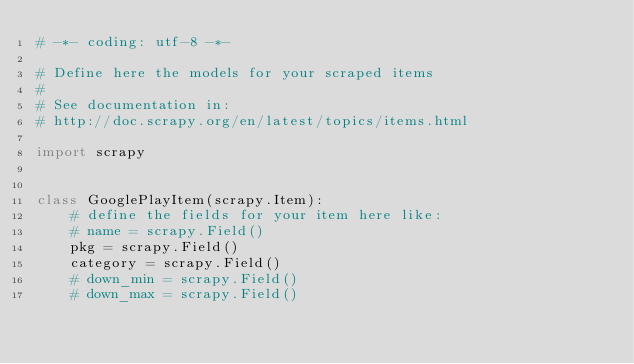Convert code to text. <code><loc_0><loc_0><loc_500><loc_500><_Python_># -*- coding: utf-8 -*-

# Define here the models for your scraped items
#
# See documentation in:
# http://doc.scrapy.org/en/latest/topics/items.html

import scrapy


class GooglePlayItem(scrapy.Item):
    # define the fields for your item here like:
    # name = scrapy.Field()
    pkg = scrapy.Field()
    category = scrapy.Field()
    # down_min = scrapy.Field()
    # down_max = scrapy.Field()
</code> 